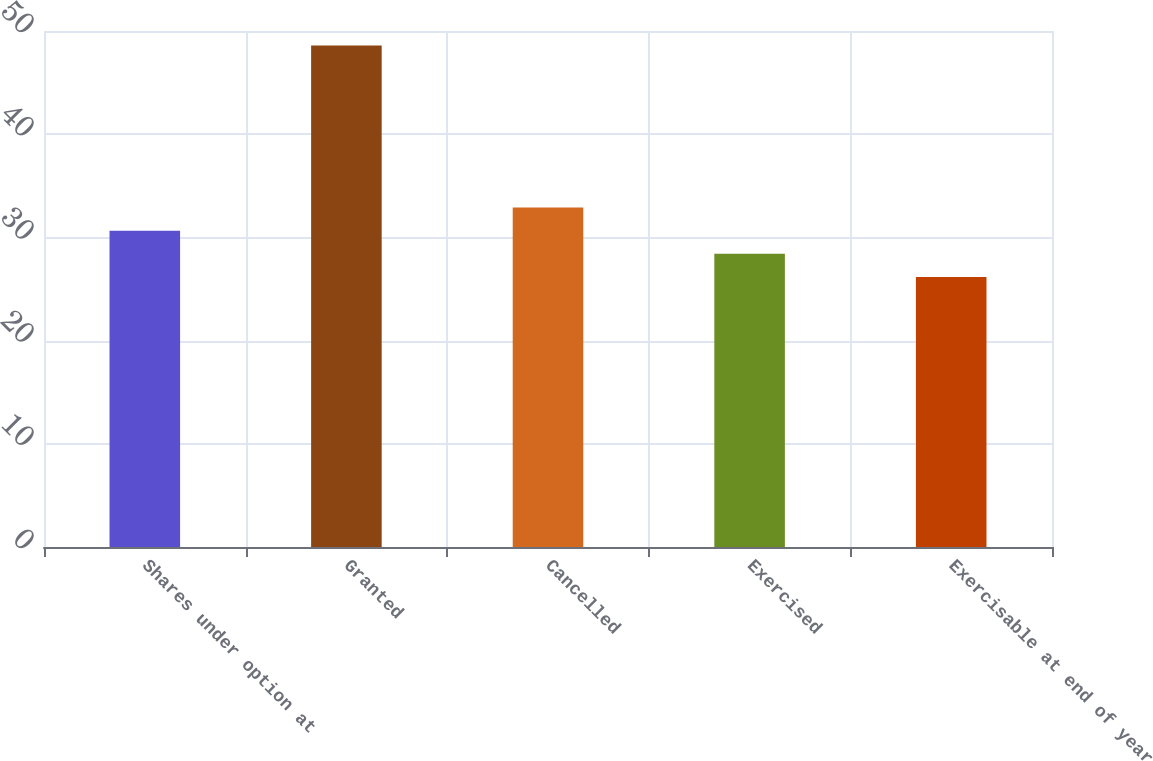Convert chart to OTSL. <chart><loc_0><loc_0><loc_500><loc_500><bar_chart><fcel>Shares under option at<fcel>Granted<fcel>Cancelled<fcel>Exercised<fcel>Exercisable at end of year<nl><fcel>30.65<fcel>48.59<fcel>32.89<fcel>28.41<fcel>26.17<nl></chart> 